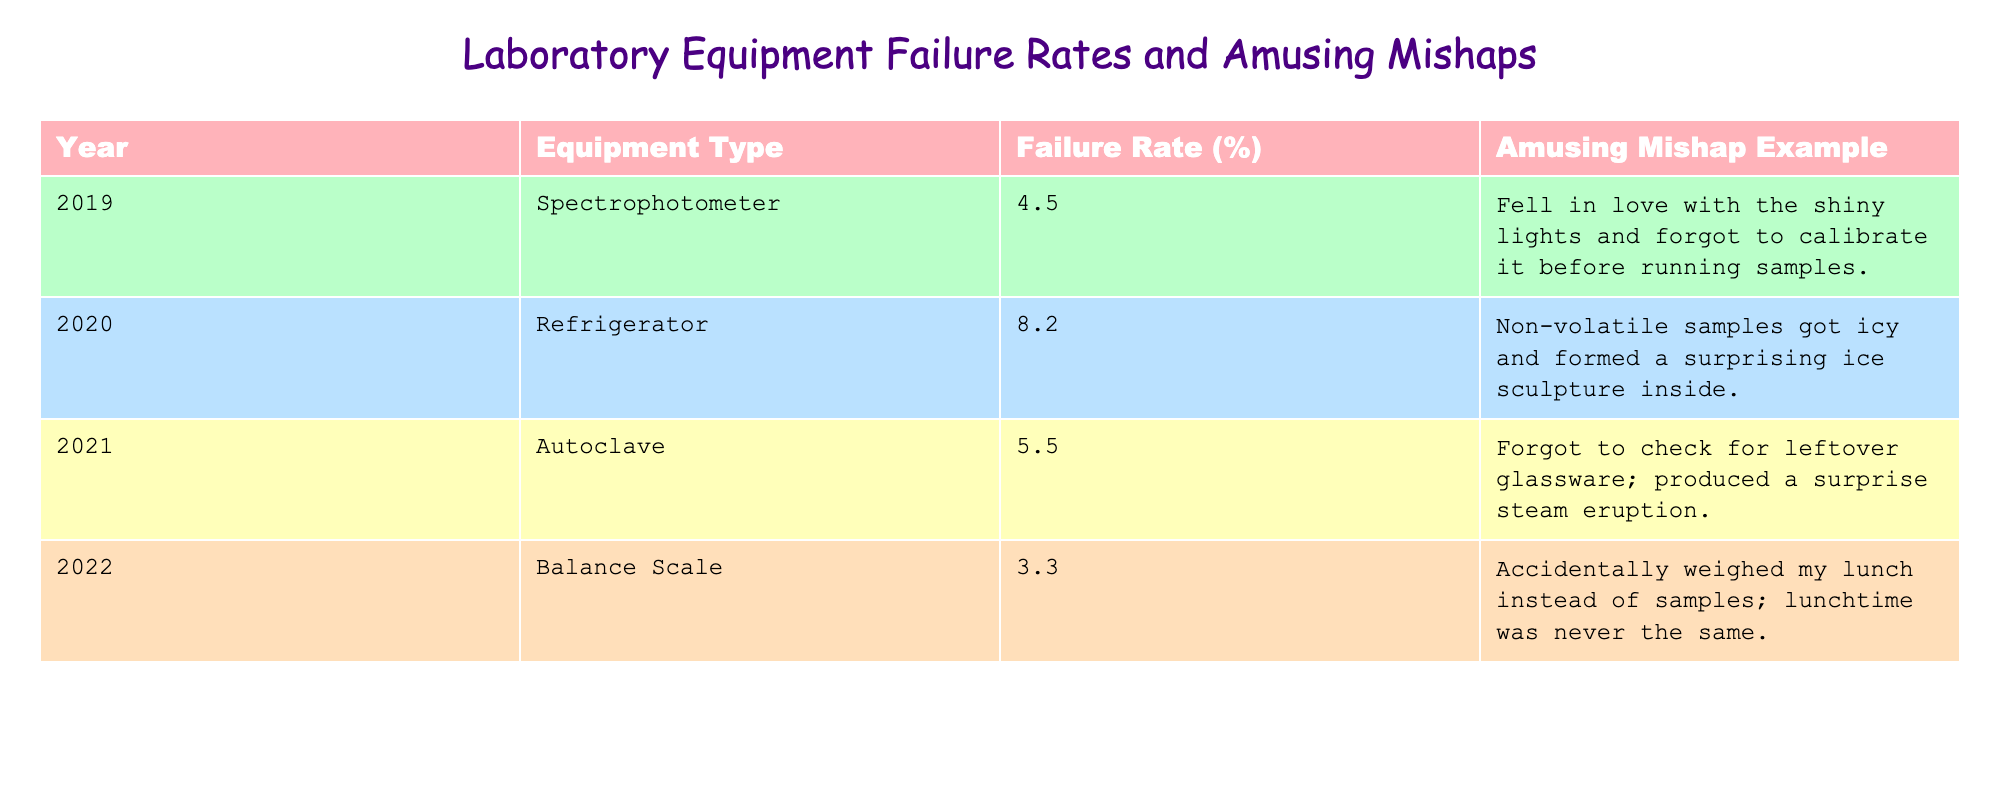What was the failure rate of the refrigerator in 2020? According to the table, the refrigerator's failure rate for the year 2020 is listed as 8.2%.
Answer: 8.2% Which equipment type experienced a failure rate of 5.5%? The table indicates that the autoclave had a failure rate of 5.5% in 2021.
Answer: Autoclave What is the average failure rate of all equipment types listed? To calculate the average, sum the failure rates (4.5 + 8.2 + 5.5 + 3.3) = 21.5%, then divide by the number of equipment types (4). The average failure rate is 21.5% / 4 = 5.375%.
Answer: 5.375% Did any equipment type have a failure rate below 4%? Upon reviewing the table, the lowest failure rate is 3.3%, attributed to the balance scale in 2022, indicating that yes, at least one equipment type had a failure rate below 4%.
Answer: Yes In which year did the balance scale experience its failure, and what was the amusing mishap associated with it? The balance scale's failure occurred in 2022, and the amusing mishap was accidentally weighing lunch instead of samples.
Answer: 2022, weighing lunch What is the difference in failure rates between the spectrophotometer and the autoclave? The failure rate for the spectrophotometer is 4.5%, and for the autoclave, it is 5.5%. To find the difference, subtract the spectrophotometer's rate from the autoclave's (5.5 - 4.5) = 1%.
Answer: 1% Which equipment type had a higher failure rate, the refrigerator or the spectrophotometer? The refrigerator had a failure rate of 8.2%, while the spectrophotometer had a failure rate of 4.5%. Since 8.2% is greater than 4.5%, the refrigerator had a higher failure rate.
Answer: Refrigerator What is the funniest mishap associated with the equipment with the highest failure rate? The equipment with the highest failure rate is the refrigerator (8.2%), and the amusing mishap is the formation of a surprising ice sculpture inside due to non-volatile samples getting icy.
Answer: Ice sculpture How many years does the table cover for laboratory equipment failure rates? The table lists data for four years: 2019, 2020, 2021, and 2022. Therefore, it covers a total of four years.
Answer: Four years 